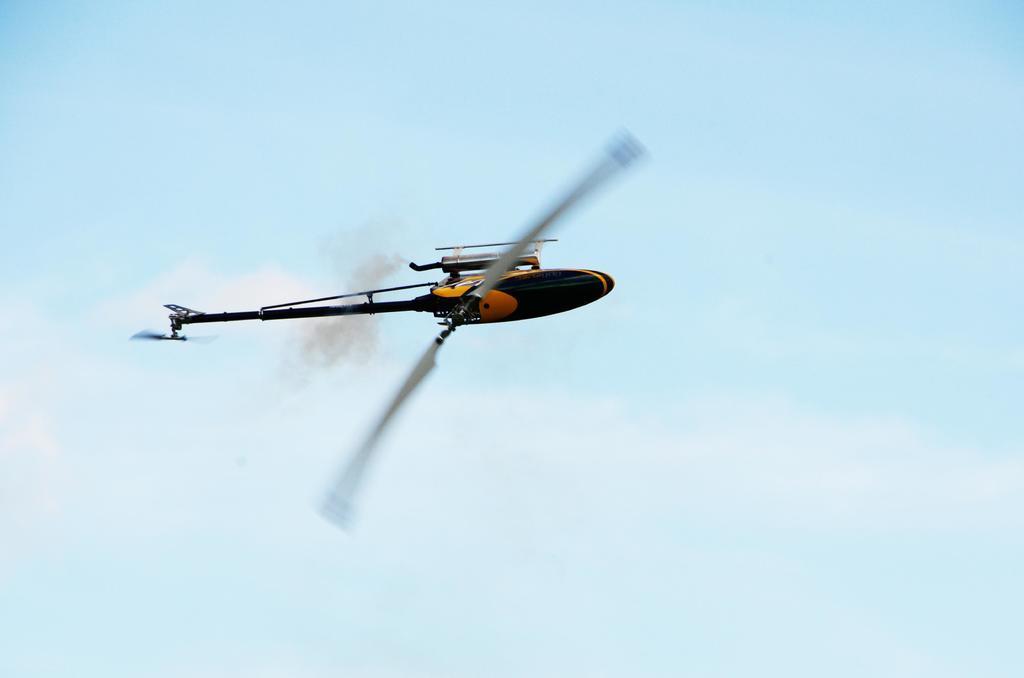Please provide a concise description of this image. This image is taken outdoors. In the background there is the sky with clouds. In the middle of the image a toy chopper is flying in the air. 